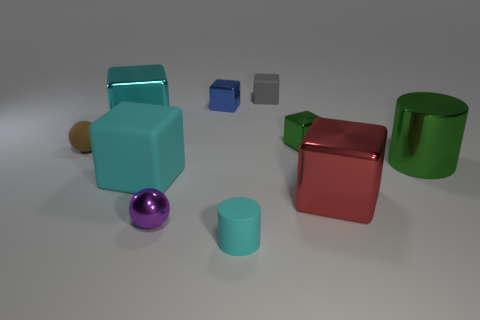Subtract all small rubber cubes. How many cubes are left? 5 Subtract 1 blocks. How many blocks are left? 5 Subtract all red cubes. How many cubes are left? 5 Subtract all brown balls. Subtract all gray cylinders. How many balls are left? 1 Subtract all red cubes. How many brown balls are left? 1 Add 6 metal cylinders. How many metal cylinders exist? 7 Subtract 0 red cylinders. How many objects are left? 10 Subtract all cylinders. How many objects are left? 8 Subtract all brown rubber balls. Subtract all large gray cylinders. How many objects are left? 9 Add 8 small shiny cubes. How many small shiny cubes are left? 10 